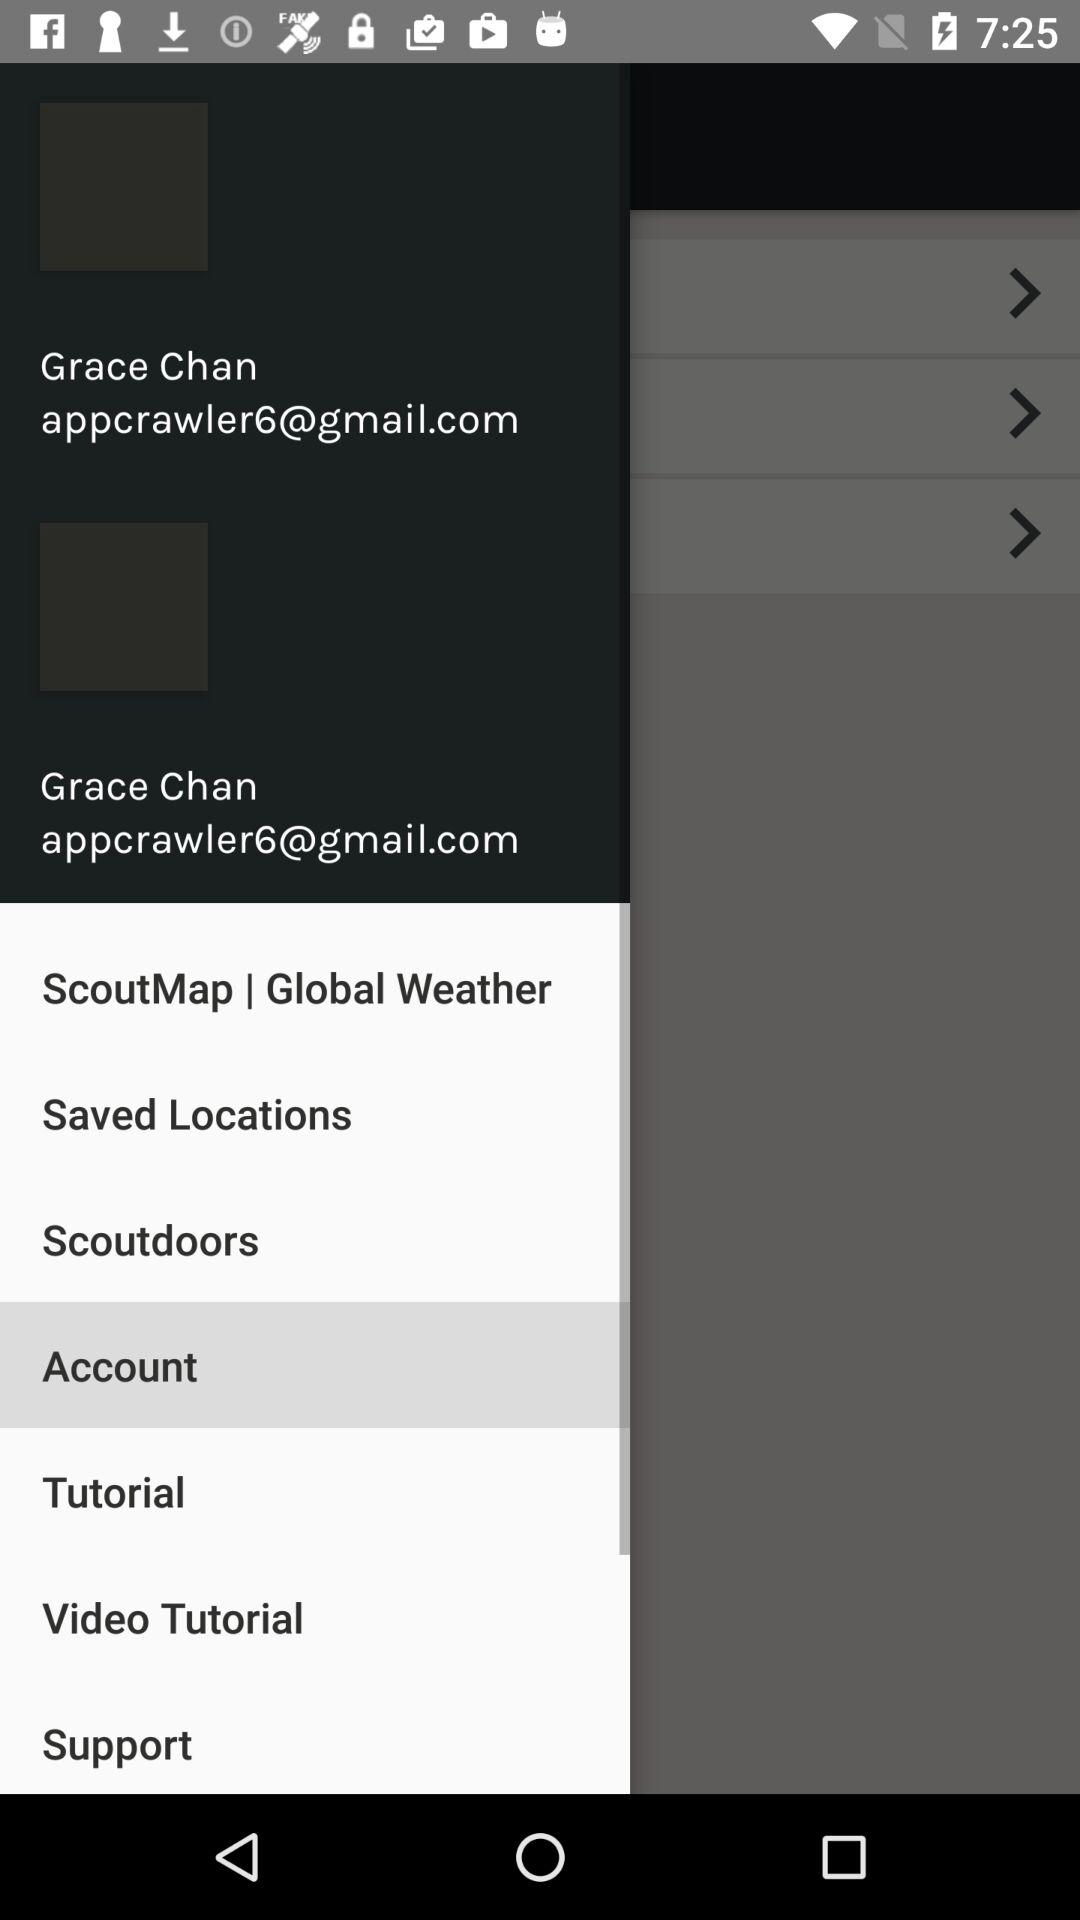What is the email address? The email address is appcrawler6@gmail.com. 